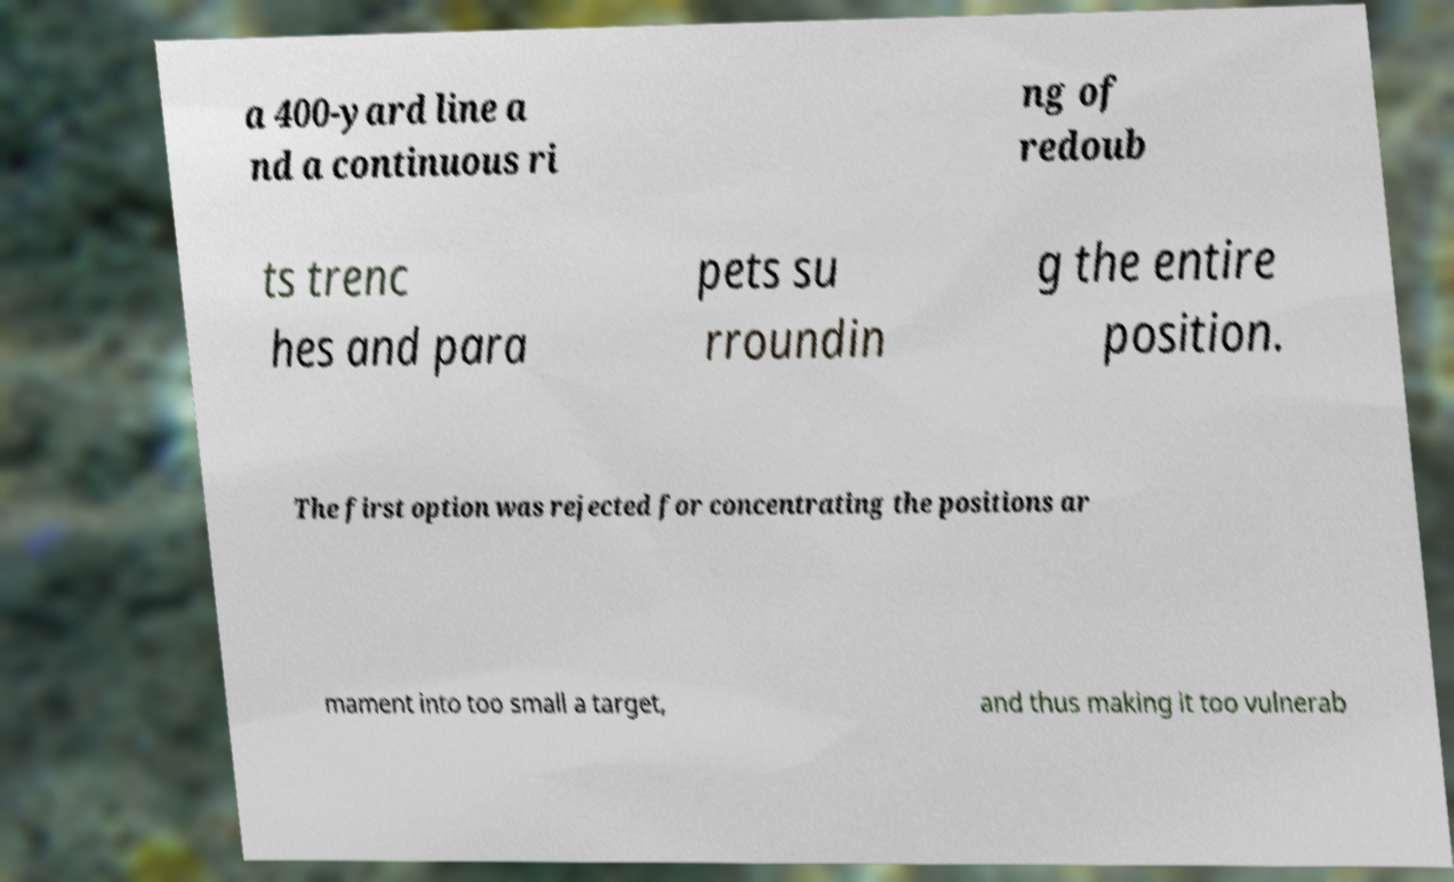Please read and relay the text visible in this image. What does it say? a 400-yard line a nd a continuous ri ng of redoub ts trenc hes and para pets su rroundin g the entire position. The first option was rejected for concentrating the positions ar mament into too small a target, and thus making it too vulnerab 